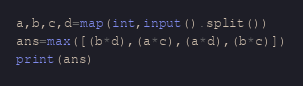Convert code to text. <code><loc_0><loc_0><loc_500><loc_500><_Python_>a,b,c,d=map(int,input().split())
ans=max([(b*d),(a*c),(a*d),(b*c)])
print(ans)</code> 